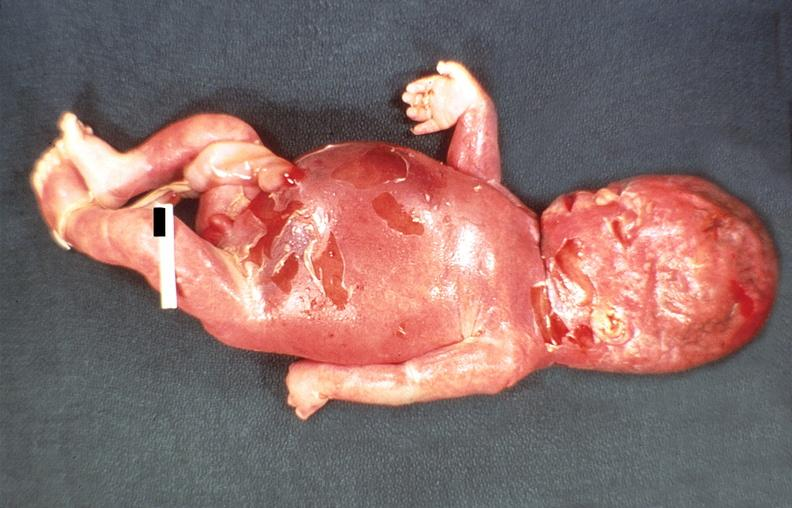what does this image show?
Answer the question using a single word or phrase. Hemolytic disease of newborn 